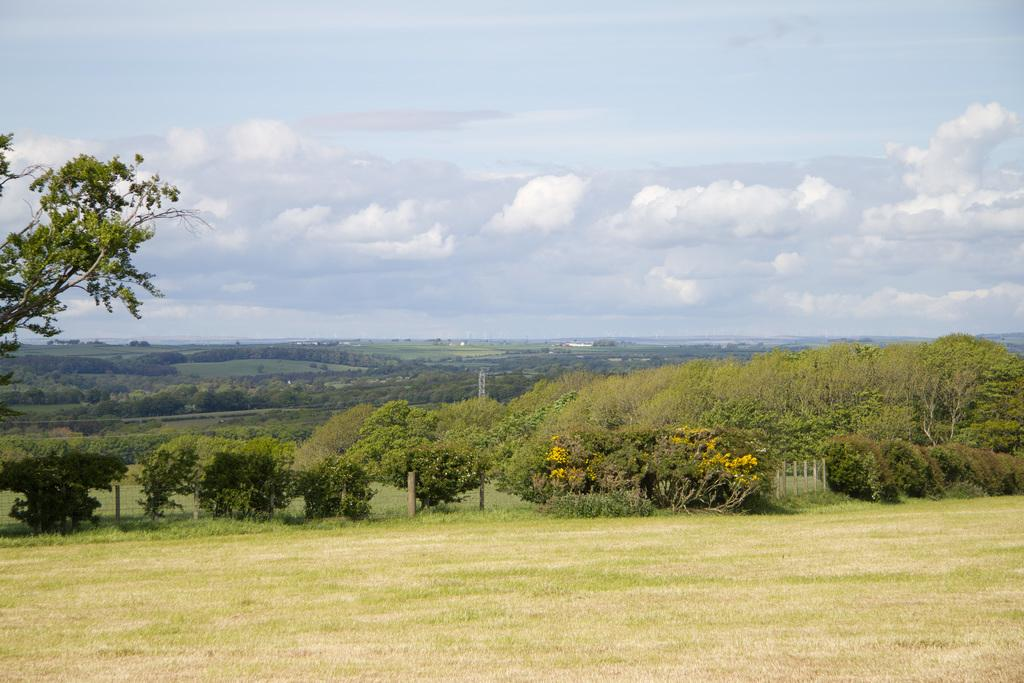What type of vegetation is present in the image? There is grass and trees in the image. What other natural elements can be seen in the image? There are rocks in the image. What is your sister's favorite example of a rock in the image? There is no information about a sister or a favorite example of a rock in the image. 